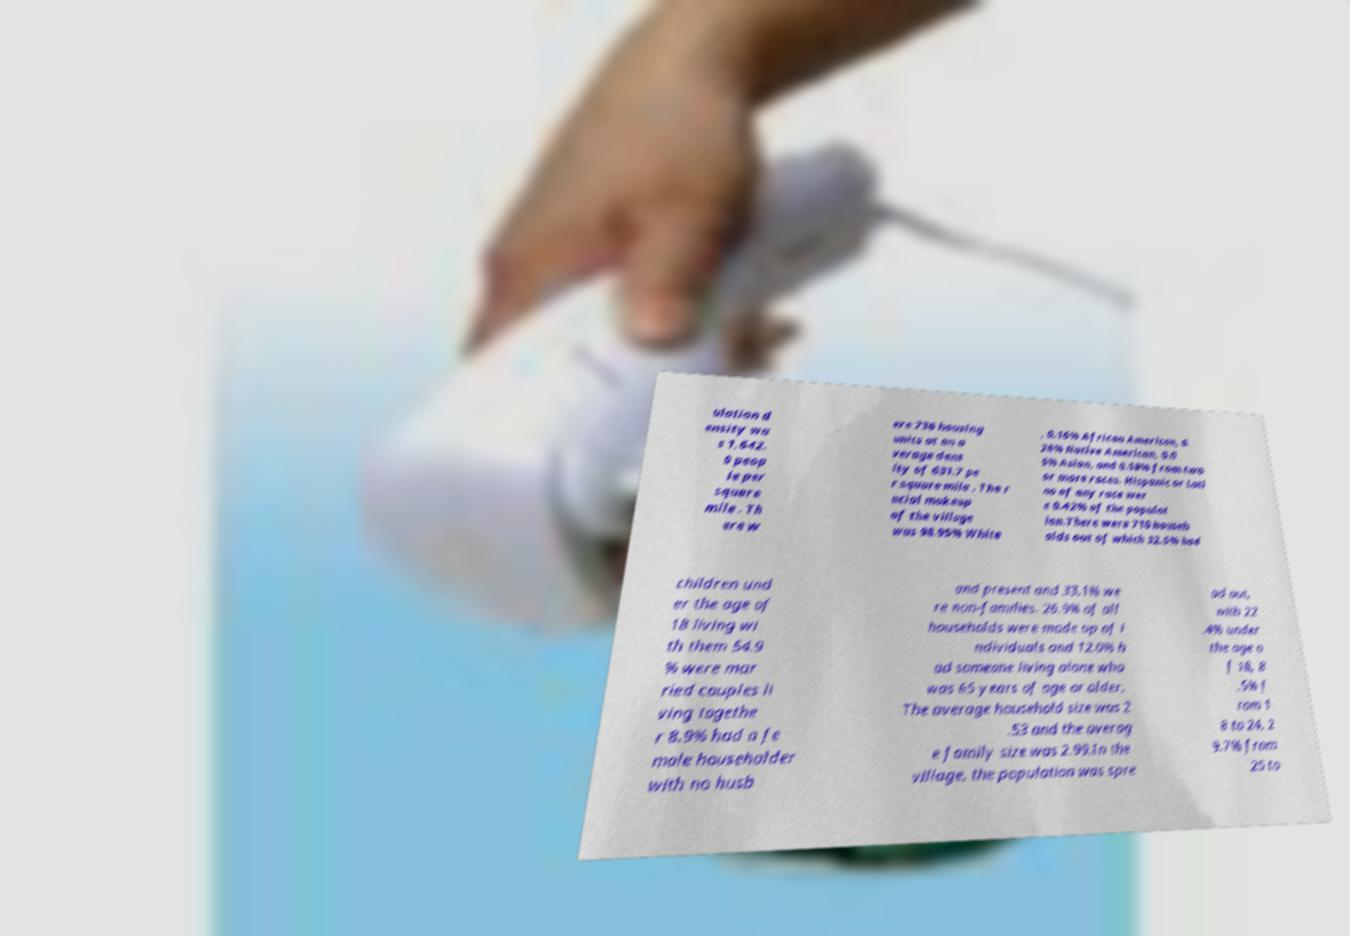Please identify and transcribe the text found in this image. ulation d ensity wa s 1,642. 0 peop le per square mile . Th ere w ere 736 housing units at an a verage dens ity of 631.7 pe r square mile . The r acial makeup of the village was 98.95% White , 0.16% African American, 0. 26% Native American, 0.0 5% Asian, and 0.58% from two or more races. Hispanic or Lati no of any race wer e 0.42% of the populat ion.There were 710 househ olds out of which 32.5% had children und er the age of 18 living wi th them 54.9 % were mar ried couples li ving togethe r 8.9% had a fe male householder with no husb and present and 33.1% we re non-families. 26.9% of all households were made up of i ndividuals and 12.0% h ad someone living alone who was 65 years of age or older. The average household size was 2 .53 and the averag e family size was 2.99.In the village, the population was spre ad out, with 22 .4% under the age o f 18, 8 .5% f rom 1 8 to 24, 2 9.7% from 25 to 